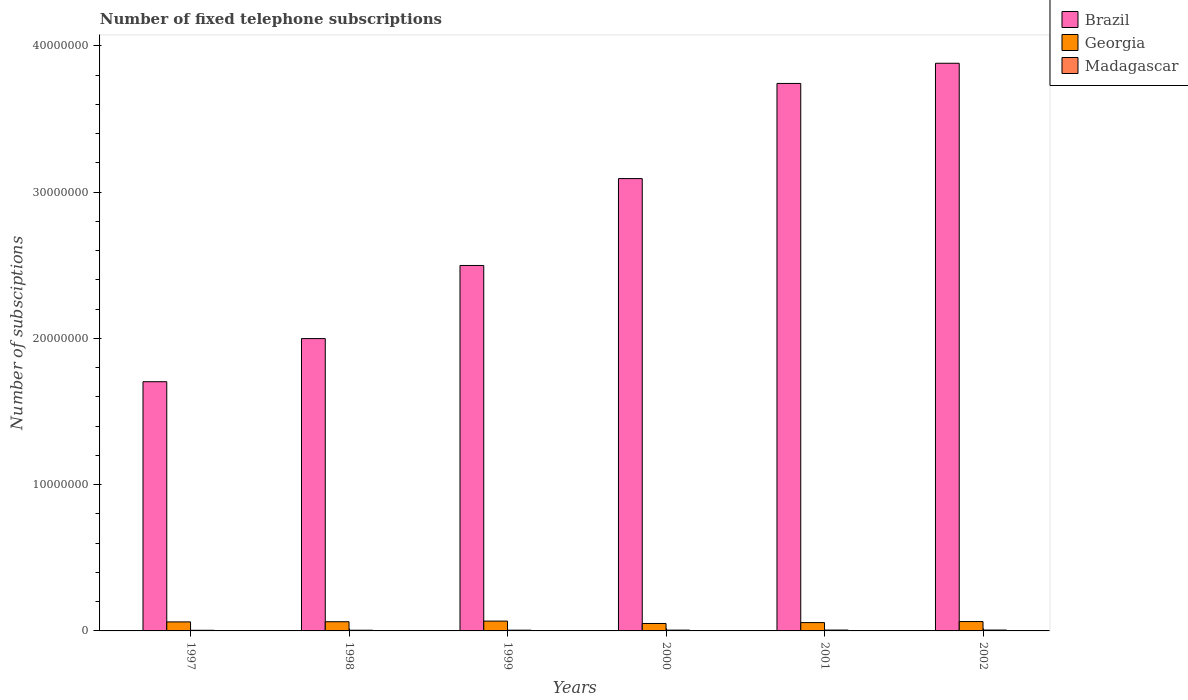How many groups of bars are there?
Provide a succinct answer. 6. Are the number of bars on each tick of the X-axis equal?
Give a very brief answer. Yes. How many bars are there on the 4th tick from the left?
Give a very brief answer. 3. How many bars are there on the 6th tick from the right?
Provide a short and direct response. 3. What is the label of the 1st group of bars from the left?
Ensure brevity in your answer.  1997. In how many cases, is the number of bars for a given year not equal to the number of legend labels?
Offer a very short reply. 0. What is the number of fixed telephone subscriptions in Georgia in 1999?
Offer a very short reply. 6.72e+05. Across all years, what is the maximum number of fixed telephone subscriptions in Georgia?
Provide a short and direct response. 6.72e+05. Across all years, what is the minimum number of fixed telephone subscriptions in Georgia?
Give a very brief answer. 5.09e+05. In which year was the number of fixed telephone subscriptions in Georgia maximum?
Offer a terse response. 1999. What is the total number of fixed telephone subscriptions in Madagascar in the graph?
Give a very brief answer. 3.14e+05. What is the difference between the number of fixed telephone subscriptions in Georgia in 2001 and that in 2002?
Give a very brief answer. -7.14e+04. What is the difference between the number of fixed telephone subscriptions in Brazil in 2001 and the number of fixed telephone subscriptions in Madagascar in 2002?
Give a very brief answer. 3.74e+07. What is the average number of fixed telephone subscriptions in Madagascar per year?
Offer a very short reply. 5.23e+04. In the year 1999, what is the difference between the number of fixed telephone subscriptions in Brazil and number of fixed telephone subscriptions in Madagascar?
Offer a very short reply. 2.49e+07. What is the ratio of the number of fixed telephone subscriptions in Georgia in 1998 to that in 1999?
Offer a very short reply. 0.94. What is the difference between the highest and the second highest number of fixed telephone subscriptions in Madagascar?
Offer a very short reply. 1092. What is the difference between the highest and the lowest number of fixed telephone subscriptions in Brazil?
Provide a succinct answer. 2.18e+07. In how many years, is the number of fixed telephone subscriptions in Brazil greater than the average number of fixed telephone subscriptions in Brazil taken over all years?
Keep it short and to the point. 3. What does the 3rd bar from the left in 2001 represents?
Give a very brief answer. Madagascar. Is it the case that in every year, the sum of the number of fixed telephone subscriptions in Brazil and number of fixed telephone subscriptions in Madagascar is greater than the number of fixed telephone subscriptions in Georgia?
Offer a very short reply. Yes. How many years are there in the graph?
Provide a succinct answer. 6. Does the graph contain any zero values?
Your response must be concise. No. Does the graph contain grids?
Give a very brief answer. No. How are the legend labels stacked?
Your answer should be very brief. Vertical. What is the title of the graph?
Your answer should be compact. Number of fixed telephone subscriptions. What is the label or title of the X-axis?
Keep it short and to the point. Years. What is the label or title of the Y-axis?
Your response must be concise. Number of subsciptions. What is the Number of subsciptions in Brazil in 1997?
Ensure brevity in your answer.  1.70e+07. What is the Number of subsciptions in Georgia in 1997?
Provide a succinct answer. 6.17e+05. What is the Number of subsciptions of Madagascar in 1997?
Offer a terse response. 4.32e+04. What is the Number of subsciptions in Brazil in 1998?
Provide a succinct answer. 2.00e+07. What is the Number of subsciptions in Georgia in 1998?
Give a very brief answer. 6.29e+05. What is the Number of subsciptions of Madagascar in 1998?
Ensure brevity in your answer.  4.72e+04. What is the Number of subsciptions in Brazil in 1999?
Make the answer very short. 2.50e+07. What is the Number of subsciptions of Georgia in 1999?
Give a very brief answer. 6.72e+05. What is the Number of subsciptions of Madagascar in 1999?
Provide a short and direct response. 5.02e+04. What is the Number of subsciptions in Brazil in 2000?
Give a very brief answer. 3.09e+07. What is the Number of subsciptions of Georgia in 2000?
Make the answer very short. 5.09e+05. What is the Number of subsciptions of Madagascar in 2000?
Give a very brief answer. 5.50e+04. What is the Number of subsciptions of Brazil in 2001?
Ensure brevity in your answer.  3.74e+07. What is the Number of subsciptions of Georgia in 2001?
Ensure brevity in your answer.  5.69e+05. What is the Number of subsciptions of Madagascar in 2001?
Give a very brief answer. 5.84e+04. What is the Number of subsciptions of Brazil in 2002?
Keep it short and to the point. 3.88e+07. What is the Number of subsciptions in Georgia in 2002?
Make the answer very short. 6.40e+05. What is the Number of subsciptions in Madagascar in 2002?
Give a very brief answer. 5.95e+04. Across all years, what is the maximum Number of subsciptions of Brazil?
Offer a very short reply. 3.88e+07. Across all years, what is the maximum Number of subsciptions in Georgia?
Offer a terse response. 6.72e+05. Across all years, what is the maximum Number of subsciptions of Madagascar?
Offer a terse response. 5.95e+04. Across all years, what is the minimum Number of subsciptions of Brazil?
Your answer should be compact. 1.70e+07. Across all years, what is the minimum Number of subsciptions of Georgia?
Offer a very short reply. 5.09e+05. Across all years, what is the minimum Number of subsciptions of Madagascar?
Keep it short and to the point. 4.32e+04. What is the total Number of subsciptions in Brazil in the graph?
Offer a very short reply. 1.69e+08. What is the total Number of subsciptions of Georgia in the graph?
Your answer should be compact. 3.63e+06. What is the total Number of subsciptions of Madagascar in the graph?
Provide a succinct answer. 3.14e+05. What is the difference between the Number of subsciptions in Brazil in 1997 and that in 1998?
Give a very brief answer. -2.95e+06. What is the difference between the Number of subsciptions of Georgia in 1997 and that in 1998?
Your answer should be compact. -1.23e+04. What is the difference between the Number of subsciptions of Madagascar in 1997 and that in 1998?
Make the answer very short. -3996. What is the difference between the Number of subsciptions in Brazil in 1997 and that in 1999?
Keep it short and to the point. -7.95e+06. What is the difference between the Number of subsciptions of Georgia in 1997 and that in 1999?
Your answer should be very brief. -5.50e+04. What is the difference between the Number of subsciptions in Madagascar in 1997 and that in 1999?
Provide a short and direct response. -7029. What is the difference between the Number of subsciptions in Brazil in 1997 and that in 2000?
Your answer should be compact. -1.39e+07. What is the difference between the Number of subsciptions in Georgia in 1997 and that in 2000?
Ensure brevity in your answer.  1.08e+05. What is the difference between the Number of subsciptions in Madagascar in 1997 and that in 2000?
Provide a short and direct response. -1.18e+04. What is the difference between the Number of subsciptions in Brazil in 1997 and that in 2001?
Provide a short and direct response. -2.04e+07. What is the difference between the Number of subsciptions in Georgia in 1997 and that in 2001?
Give a very brief answer. 4.75e+04. What is the difference between the Number of subsciptions in Madagascar in 1997 and that in 2001?
Keep it short and to the point. -1.52e+04. What is the difference between the Number of subsciptions of Brazil in 1997 and that in 2002?
Offer a terse response. -2.18e+07. What is the difference between the Number of subsciptions in Georgia in 1997 and that in 2002?
Your answer should be very brief. -2.39e+04. What is the difference between the Number of subsciptions in Madagascar in 1997 and that in 2002?
Offer a terse response. -1.63e+04. What is the difference between the Number of subsciptions of Brazil in 1998 and that in 1999?
Offer a very short reply. -5.00e+06. What is the difference between the Number of subsciptions of Georgia in 1998 and that in 1999?
Your answer should be very brief. -4.27e+04. What is the difference between the Number of subsciptions in Madagascar in 1998 and that in 1999?
Give a very brief answer. -3033. What is the difference between the Number of subsciptions in Brazil in 1998 and that in 2000?
Offer a very short reply. -1.09e+07. What is the difference between the Number of subsciptions of Georgia in 1998 and that in 2000?
Make the answer very short. 1.20e+05. What is the difference between the Number of subsciptions in Madagascar in 1998 and that in 2000?
Your response must be concise. -7802. What is the difference between the Number of subsciptions of Brazil in 1998 and that in 2001?
Your response must be concise. -1.74e+07. What is the difference between the Number of subsciptions of Georgia in 1998 and that in 2001?
Your response must be concise. 5.97e+04. What is the difference between the Number of subsciptions in Madagascar in 1998 and that in 2001?
Give a very brief answer. -1.12e+04. What is the difference between the Number of subsciptions of Brazil in 1998 and that in 2002?
Ensure brevity in your answer.  -1.88e+07. What is the difference between the Number of subsciptions of Georgia in 1998 and that in 2002?
Give a very brief answer. -1.16e+04. What is the difference between the Number of subsciptions in Madagascar in 1998 and that in 2002?
Your answer should be very brief. -1.23e+04. What is the difference between the Number of subsciptions of Brazil in 1999 and that in 2000?
Your answer should be very brief. -5.94e+06. What is the difference between the Number of subsciptions of Georgia in 1999 and that in 2000?
Provide a short and direct response. 1.63e+05. What is the difference between the Number of subsciptions of Madagascar in 1999 and that in 2000?
Your answer should be very brief. -4769. What is the difference between the Number of subsciptions of Brazil in 1999 and that in 2001?
Offer a very short reply. -1.24e+07. What is the difference between the Number of subsciptions of Georgia in 1999 and that in 2001?
Make the answer very short. 1.02e+05. What is the difference between the Number of subsciptions of Madagascar in 1999 and that in 2001?
Offer a very short reply. -8173. What is the difference between the Number of subsciptions of Brazil in 1999 and that in 2002?
Your answer should be very brief. -1.38e+07. What is the difference between the Number of subsciptions of Georgia in 1999 and that in 2002?
Offer a terse response. 3.11e+04. What is the difference between the Number of subsciptions of Madagascar in 1999 and that in 2002?
Offer a very short reply. -9265. What is the difference between the Number of subsciptions of Brazil in 2000 and that in 2001?
Provide a succinct answer. -6.50e+06. What is the difference between the Number of subsciptions of Georgia in 2000 and that in 2001?
Your response must be concise. -6.03e+04. What is the difference between the Number of subsciptions in Madagascar in 2000 and that in 2001?
Make the answer very short. -3404. What is the difference between the Number of subsciptions in Brazil in 2000 and that in 2002?
Ensure brevity in your answer.  -7.88e+06. What is the difference between the Number of subsciptions in Georgia in 2000 and that in 2002?
Provide a short and direct response. -1.32e+05. What is the difference between the Number of subsciptions in Madagascar in 2000 and that in 2002?
Ensure brevity in your answer.  -4496. What is the difference between the Number of subsciptions in Brazil in 2001 and that in 2002?
Ensure brevity in your answer.  -1.38e+06. What is the difference between the Number of subsciptions in Georgia in 2001 and that in 2002?
Give a very brief answer. -7.14e+04. What is the difference between the Number of subsciptions of Madagascar in 2001 and that in 2002?
Ensure brevity in your answer.  -1092. What is the difference between the Number of subsciptions in Brazil in 1997 and the Number of subsciptions in Georgia in 1998?
Provide a short and direct response. 1.64e+07. What is the difference between the Number of subsciptions in Brazil in 1997 and the Number of subsciptions in Madagascar in 1998?
Your answer should be very brief. 1.70e+07. What is the difference between the Number of subsciptions in Georgia in 1997 and the Number of subsciptions in Madagascar in 1998?
Offer a very short reply. 5.69e+05. What is the difference between the Number of subsciptions of Brazil in 1997 and the Number of subsciptions of Georgia in 1999?
Your answer should be very brief. 1.64e+07. What is the difference between the Number of subsciptions in Brazil in 1997 and the Number of subsciptions in Madagascar in 1999?
Your response must be concise. 1.70e+07. What is the difference between the Number of subsciptions of Georgia in 1997 and the Number of subsciptions of Madagascar in 1999?
Ensure brevity in your answer.  5.66e+05. What is the difference between the Number of subsciptions in Brazil in 1997 and the Number of subsciptions in Georgia in 2000?
Ensure brevity in your answer.  1.65e+07. What is the difference between the Number of subsciptions of Brazil in 1997 and the Number of subsciptions of Madagascar in 2000?
Offer a terse response. 1.70e+07. What is the difference between the Number of subsciptions in Georgia in 1997 and the Number of subsciptions in Madagascar in 2000?
Offer a very short reply. 5.62e+05. What is the difference between the Number of subsciptions in Brazil in 1997 and the Number of subsciptions in Georgia in 2001?
Your answer should be very brief. 1.65e+07. What is the difference between the Number of subsciptions in Brazil in 1997 and the Number of subsciptions in Madagascar in 2001?
Your answer should be very brief. 1.70e+07. What is the difference between the Number of subsciptions of Georgia in 1997 and the Number of subsciptions of Madagascar in 2001?
Keep it short and to the point. 5.58e+05. What is the difference between the Number of subsciptions of Brazil in 1997 and the Number of subsciptions of Georgia in 2002?
Give a very brief answer. 1.64e+07. What is the difference between the Number of subsciptions in Brazil in 1997 and the Number of subsciptions in Madagascar in 2002?
Your response must be concise. 1.70e+07. What is the difference between the Number of subsciptions in Georgia in 1997 and the Number of subsciptions in Madagascar in 2002?
Your answer should be very brief. 5.57e+05. What is the difference between the Number of subsciptions of Brazil in 1998 and the Number of subsciptions of Georgia in 1999?
Make the answer very short. 1.93e+07. What is the difference between the Number of subsciptions in Brazil in 1998 and the Number of subsciptions in Madagascar in 1999?
Ensure brevity in your answer.  1.99e+07. What is the difference between the Number of subsciptions in Georgia in 1998 and the Number of subsciptions in Madagascar in 1999?
Offer a terse response. 5.79e+05. What is the difference between the Number of subsciptions of Brazil in 1998 and the Number of subsciptions of Georgia in 2000?
Offer a very short reply. 1.95e+07. What is the difference between the Number of subsciptions in Brazil in 1998 and the Number of subsciptions in Madagascar in 2000?
Give a very brief answer. 1.99e+07. What is the difference between the Number of subsciptions in Georgia in 1998 and the Number of subsciptions in Madagascar in 2000?
Your answer should be compact. 5.74e+05. What is the difference between the Number of subsciptions of Brazil in 1998 and the Number of subsciptions of Georgia in 2001?
Your response must be concise. 1.94e+07. What is the difference between the Number of subsciptions in Brazil in 1998 and the Number of subsciptions in Madagascar in 2001?
Ensure brevity in your answer.  1.99e+07. What is the difference between the Number of subsciptions in Georgia in 1998 and the Number of subsciptions in Madagascar in 2001?
Keep it short and to the point. 5.70e+05. What is the difference between the Number of subsciptions of Brazil in 1998 and the Number of subsciptions of Georgia in 2002?
Keep it short and to the point. 1.93e+07. What is the difference between the Number of subsciptions of Brazil in 1998 and the Number of subsciptions of Madagascar in 2002?
Give a very brief answer. 1.99e+07. What is the difference between the Number of subsciptions of Georgia in 1998 and the Number of subsciptions of Madagascar in 2002?
Give a very brief answer. 5.69e+05. What is the difference between the Number of subsciptions of Brazil in 1999 and the Number of subsciptions of Georgia in 2000?
Ensure brevity in your answer.  2.45e+07. What is the difference between the Number of subsciptions in Brazil in 1999 and the Number of subsciptions in Madagascar in 2000?
Ensure brevity in your answer.  2.49e+07. What is the difference between the Number of subsciptions in Georgia in 1999 and the Number of subsciptions in Madagascar in 2000?
Give a very brief answer. 6.17e+05. What is the difference between the Number of subsciptions in Brazil in 1999 and the Number of subsciptions in Georgia in 2001?
Offer a very short reply. 2.44e+07. What is the difference between the Number of subsciptions of Brazil in 1999 and the Number of subsciptions of Madagascar in 2001?
Your answer should be compact. 2.49e+07. What is the difference between the Number of subsciptions of Georgia in 1999 and the Number of subsciptions of Madagascar in 2001?
Offer a terse response. 6.13e+05. What is the difference between the Number of subsciptions in Brazil in 1999 and the Number of subsciptions in Georgia in 2002?
Provide a short and direct response. 2.43e+07. What is the difference between the Number of subsciptions in Brazil in 1999 and the Number of subsciptions in Madagascar in 2002?
Give a very brief answer. 2.49e+07. What is the difference between the Number of subsciptions in Georgia in 1999 and the Number of subsciptions in Madagascar in 2002?
Your answer should be very brief. 6.12e+05. What is the difference between the Number of subsciptions in Brazil in 2000 and the Number of subsciptions in Georgia in 2001?
Keep it short and to the point. 3.04e+07. What is the difference between the Number of subsciptions of Brazil in 2000 and the Number of subsciptions of Madagascar in 2001?
Make the answer very short. 3.09e+07. What is the difference between the Number of subsciptions in Georgia in 2000 and the Number of subsciptions in Madagascar in 2001?
Your response must be concise. 4.50e+05. What is the difference between the Number of subsciptions of Brazil in 2000 and the Number of subsciptions of Georgia in 2002?
Your response must be concise. 3.03e+07. What is the difference between the Number of subsciptions in Brazil in 2000 and the Number of subsciptions in Madagascar in 2002?
Your response must be concise. 3.09e+07. What is the difference between the Number of subsciptions of Georgia in 2000 and the Number of subsciptions of Madagascar in 2002?
Provide a short and direct response. 4.49e+05. What is the difference between the Number of subsciptions of Brazil in 2001 and the Number of subsciptions of Georgia in 2002?
Ensure brevity in your answer.  3.68e+07. What is the difference between the Number of subsciptions in Brazil in 2001 and the Number of subsciptions in Madagascar in 2002?
Ensure brevity in your answer.  3.74e+07. What is the difference between the Number of subsciptions of Georgia in 2001 and the Number of subsciptions of Madagascar in 2002?
Ensure brevity in your answer.  5.10e+05. What is the average Number of subsciptions in Brazil per year?
Offer a terse response. 2.82e+07. What is the average Number of subsciptions in Georgia per year?
Your answer should be compact. 6.06e+05. What is the average Number of subsciptions of Madagascar per year?
Give a very brief answer. 5.23e+04. In the year 1997, what is the difference between the Number of subsciptions of Brazil and Number of subsciptions of Georgia?
Your response must be concise. 1.64e+07. In the year 1997, what is the difference between the Number of subsciptions in Brazil and Number of subsciptions in Madagascar?
Make the answer very short. 1.70e+07. In the year 1997, what is the difference between the Number of subsciptions in Georgia and Number of subsciptions in Madagascar?
Offer a terse response. 5.73e+05. In the year 1998, what is the difference between the Number of subsciptions of Brazil and Number of subsciptions of Georgia?
Offer a very short reply. 1.94e+07. In the year 1998, what is the difference between the Number of subsciptions in Brazil and Number of subsciptions in Madagascar?
Offer a very short reply. 1.99e+07. In the year 1998, what is the difference between the Number of subsciptions in Georgia and Number of subsciptions in Madagascar?
Keep it short and to the point. 5.82e+05. In the year 1999, what is the difference between the Number of subsciptions in Brazil and Number of subsciptions in Georgia?
Your answer should be compact. 2.43e+07. In the year 1999, what is the difference between the Number of subsciptions in Brazil and Number of subsciptions in Madagascar?
Your response must be concise. 2.49e+07. In the year 1999, what is the difference between the Number of subsciptions of Georgia and Number of subsciptions of Madagascar?
Offer a terse response. 6.21e+05. In the year 2000, what is the difference between the Number of subsciptions in Brazil and Number of subsciptions in Georgia?
Your answer should be compact. 3.04e+07. In the year 2000, what is the difference between the Number of subsciptions in Brazil and Number of subsciptions in Madagascar?
Offer a terse response. 3.09e+07. In the year 2000, what is the difference between the Number of subsciptions in Georgia and Number of subsciptions in Madagascar?
Provide a succinct answer. 4.54e+05. In the year 2001, what is the difference between the Number of subsciptions of Brazil and Number of subsciptions of Georgia?
Ensure brevity in your answer.  3.69e+07. In the year 2001, what is the difference between the Number of subsciptions in Brazil and Number of subsciptions in Madagascar?
Your answer should be very brief. 3.74e+07. In the year 2001, what is the difference between the Number of subsciptions of Georgia and Number of subsciptions of Madagascar?
Give a very brief answer. 5.11e+05. In the year 2002, what is the difference between the Number of subsciptions in Brazil and Number of subsciptions in Georgia?
Your answer should be compact. 3.82e+07. In the year 2002, what is the difference between the Number of subsciptions in Brazil and Number of subsciptions in Madagascar?
Provide a succinct answer. 3.88e+07. In the year 2002, what is the difference between the Number of subsciptions of Georgia and Number of subsciptions of Madagascar?
Ensure brevity in your answer.  5.81e+05. What is the ratio of the Number of subsciptions of Brazil in 1997 to that in 1998?
Keep it short and to the point. 0.85. What is the ratio of the Number of subsciptions in Georgia in 1997 to that in 1998?
Give a very brief answer. 0.98. What is the ratio of the Number of subsciptions of Madagascar in 1997 to that in 1998?
Provide a short and direct response. 0.92. What is the ratio of the Number of subsciptions of Brazil in 1997 to that in 1999?
Give a very brief answer. 0.68. What is the ratio of the Number of subsciptions in Georgia in 1997 to that in 1999?
Give a very brief answer. 0.92. What is the ratio of the Number of subsciptions in Madagascar in 1997 to that in 1999?
Provide a succinct answer. 0.86. What is the ratio of the Number of subsciptions of Brazil in 1997 to that in 2000?
Your response must be concise. 0.55. What is the ratio of the Number of subsciptions in Georgia in 1997 to that in 2000?
Ensure brevity in your answer.  1.21. What is the ratio of the Number of subsciptions in Madagascar in 1997 to that in 2000?
Your answer should be very brief. 0.79. What is the ratio of the Number of subsciptions of Brazil in 1997 to that in 2001?
Provide a short and direct response. 0.46. What is the ratio of the Number of subsciptions of Georgia in 1997 to that in 2001?
Provide a succinct answer. 1.08. What is the ratio of the Number of subsciptions of Madagascar in 1997 to that in 2001?
Provide a succinct answer. 0.74. What is the ratio of the Number of subsciptions in Brazil in 1997 to that in 2002?
Offer a terse response. 0.44. What is the ratio of the Number of subsciptions of Georgia in 1997 to that in 2002?
Provide a succinct answer. 0.96. What is the ratio of the Number of subsciptions of Madagascar in 1997 to that in 2002?
Give a very brief answer. 0.73. What is the ratio of the Number of subsciptions in Brazil in 1998 to that in 1999?
Give a very brief answer. 0.8. What is the ratio of the Number of subsciptions of Georgia in 1998 to that in 1999?
Your response must be concise. 0.94. What is the ratio of the Number of subsciptions of Madagascar in 1998 to that in 1999?
Make the answer very short. 0.94. What is the ratio of the Number of subsciptions in Brazil in 1998 to that in 2000?
Your response must be concise. 0.65. What is the ratio of the Number of subsciptions in Georgia in 1998 to that in 2000?
Give a very brief answer. 1.24. What is the ratio of the Number of subsciptions of Madagascar in 1998 to that in 2000?
Keep it short and to the point. 0.86. What is the ratio of the Number of subsciptions in Brazil in 1998 to that in 2001?
Give a very brief answer. 0.53. What is the ratio of the Number of subsciptions of Georgia in 1998 to that in 2001?
Your answer should be very brief. 1.1. What is the ratio of the Number of subsciptions of Madagascar in 1998 to that in 2001?
Your response must be concise. 0.81. What is the ratio of the Number of subsciptions in Brazil in 1998 to that in 2002?
Provide a short and direct response. 0.52. What is the ratio of the Number of subsciptions in Georgia in 1998 to that in 2002?
Provide a short and direct response. 0.98. What is the ratio of the Number of subsciptions in Madagascar in 1998 to that in 2002?
Provide a succinct answer. 0.79. What is the ratio of the Number of subsciptions of Brazil in 1999 to that in 2000?
Your response must be concise. 0.81. What is the ratio of the Number of subsciptions of Georgia in 1999 to that in 2000?
Your answer should be very brief. 1.32. What is the ratio of the Number of subsciptions in Madagascar in 1999 to that in 2000?
Your answer should be compact. 0.91. What is the ratio of the Number of subsciptions of Brazil in 1999 to that in 2001?
Provide a short and direct response. 0.67. What is the ratio of the Number of subsciptions in Georgia in 1999 to that in 2001?
Keep it short and to the point. 1.18. What is the ratio of the Number of subsciptions of Madagascar in 1999 to that in 2001?
Offer a very short reply. 0.86. What is the ratio of the Number of subsciptions in Brazil in 1999 to that in 2002?
Your answer should be compact. 0.64. What is the ratio of the Number of subsciptions in Georgia in 1999 to that in 2002?
Make the answer very short. 1.05. What is the ratio of the Number of subsciptions in Madagascar in 1999 to that in 2002?
Keep it short and to the point. 0.84. What is the ratio of the Number of subsciptions of Brazil in 2000 to that in 2001?
Provide a short and direct response. 0.83. What is the ratio of the Number of subsciptions in Georgia in 2000 to that in 2001?
Offer a terse response. 0.89. What is the ratio of the Number of subsciptions in Madagascar in 2000 to that in 2001?
Keep it short and to the point. 0.94. What is the ratio of the Number of subsciptions of Brazil in 2000 to that in 2002?
Offer a very short reply. 0.8. What is the ratio of the Number of subsciptions of Georgia in 2000 to that in 2002?
Provide a succinct answer. 0.79. What is the ratio of the Number of subsciptions of Madagascar in 2000 to that in 2002?
Offer a terse response. 0.92. What is the ratio of the Number of subsciptions of Brazil in 2001 to that in 2002?
Your response must be concise. 0.96. What is the ratio of the Number of subsciptions in Georgia in 2001 to that in 2002?
Ensure brevity in your answer.  0.89. What is the ratio of the Number of subsciptions in Madagascar in 2001 to that in 2002?
Keep it short and to the point. 0.98. What is the difference between the highest and the second highest Number of subsciptions in Brazil?
Provide a succinct answer. 1.38e+06. What is the difference between the highest and the second highest Number of subsciptions of Georgia?
Provide a succinct answer. 3.11e+04. What is the difference between the highest and the second highest Number of subsciptions of Madagascar?
Your response must be concise. 1092. What is the difference between the highest and the lowest Number of subsciptions of Brazil?
Provide a succinct answer. 2.18e+07. What is the difference between the highest and the lowest Number of subsciptions in Georgia?
Keep it short and to the point. 1.63e+05. What is the difference between the highest and the lowest Number of subsciptions in Madagascar?
Offer a very short reply. 1.63e+04. 